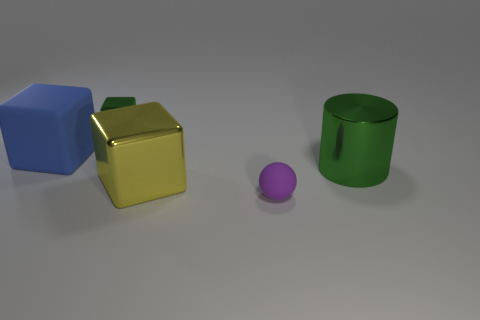There is a large object left of the tiny metallic thing; what number of large blue blocks are on the left side of it?
Ensure brevity in your answer.  0. Are there fewer tiny green cubes that are on the left side of the tiny green cube than tiny blue rubber cubes?
Your answer should be very brief. No. The green metallic object that is in front of the thing to the left of the small object on the left side of the purple rubber ball is what shape?
Keep it short and to the point. Cylinder. Is the small green metallic thing the same shape as the tiny matte object?
Your answer should be very brief. No. What number of other things are there of the same shape as the big yellow object?
Your answer should be compact. 2. What is the color of the other block that is the same size as the blue matte block?
Provide a short and direct response. Yellow. Are there the same number of big blue matte objects that are right of the large yellow shiny object and yellow matte cylinders?
Provide a short and direct response. Yes. There is a thing that is to the left of the yellow block and in front of the tiny green metal block; what shape is it?
Provide a succinct answer. Cube. Is the size of the blue block the same as the purple ball?
Your response must be concise. No. Are there any tiny green blocks made of the same material as the yellow object?
Give a very brief answer. Yes. 